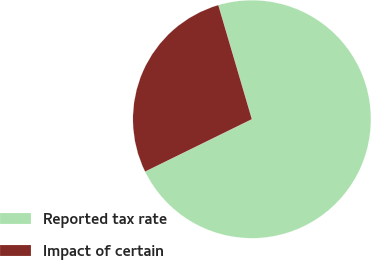Convert chart. <chart><loc_0><loc_0><loc_500><loc_500><pie_chart><fcel>Reported tax rate<fcel>Impact of certain<nl><fcel>72.29%<fcel>27.71%<nl></chart> 